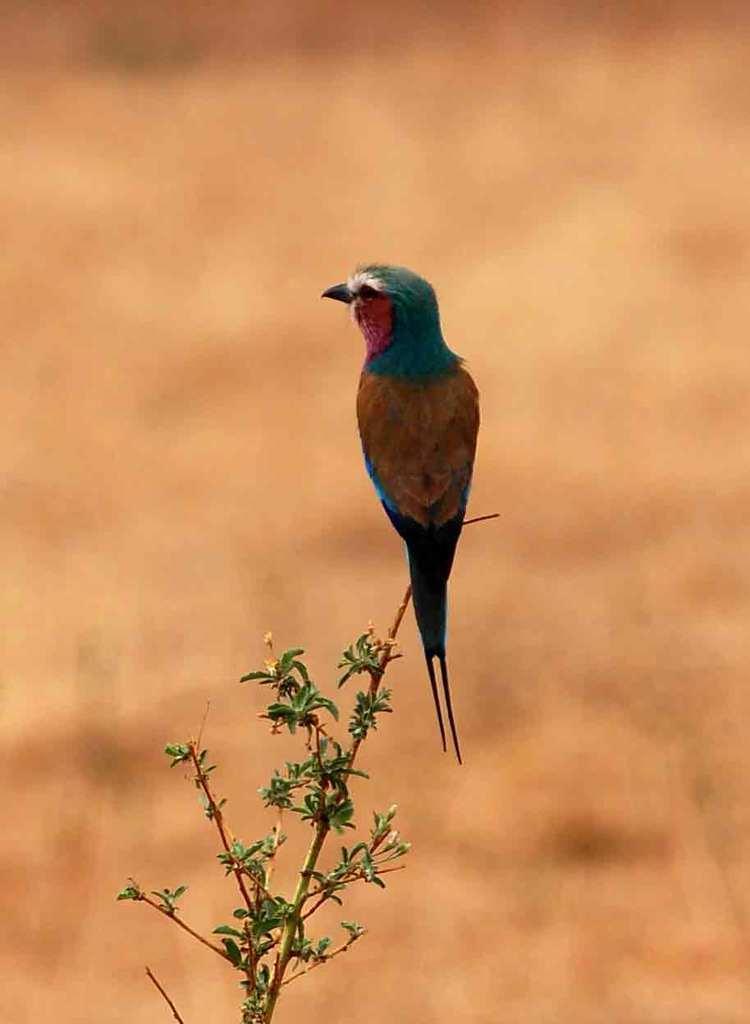How would you summarize this image in a sentence or two? This is the picture of a bird, the background is blurred because the bird is focused in this picture and the bird is stand on the plant and these are the leaves. 